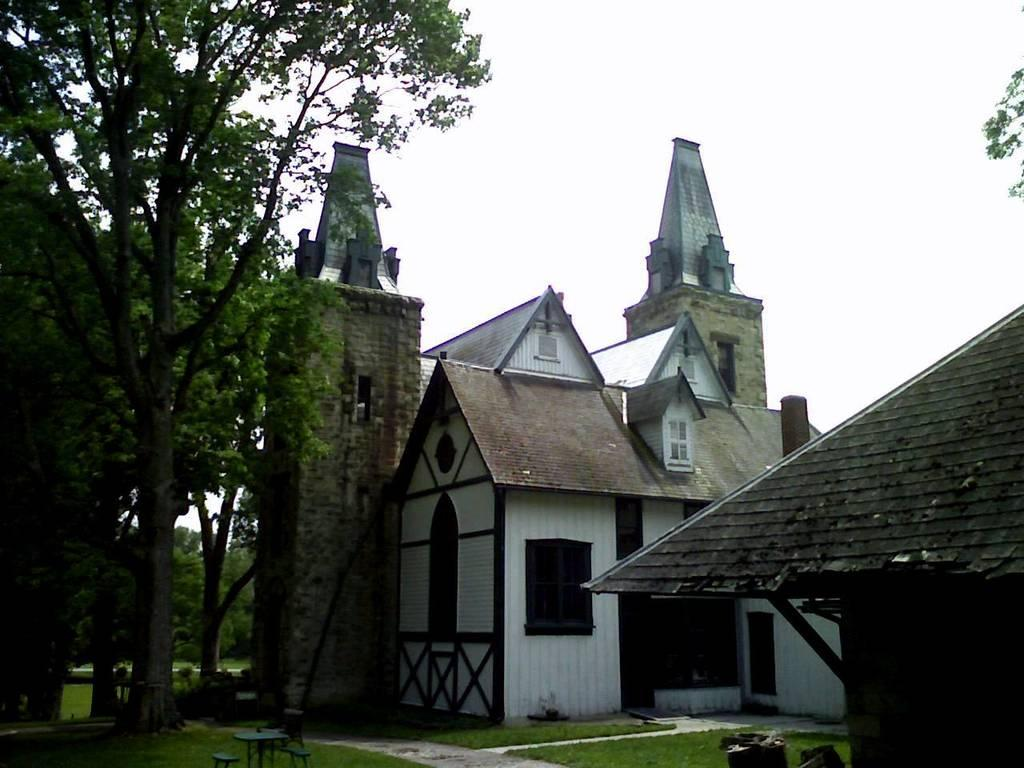What type of vegetation is present in the image? There is grass in the image. What type of furniture is visible in the image? There are benches in the image. What type of structure is present in the image? There are buildings in the image. What type of natural elements are present in the image? There are trees in the image. What type of objects are present in the image? There are some objects in the image. What is visible in the background of the image? The sky is visible in the background of the image. Can you guide me through the cave that is present in the image? There is no cave present in the image; it features grass, a table, benches, buildings, trees, objects, and a visible sky in the background. 